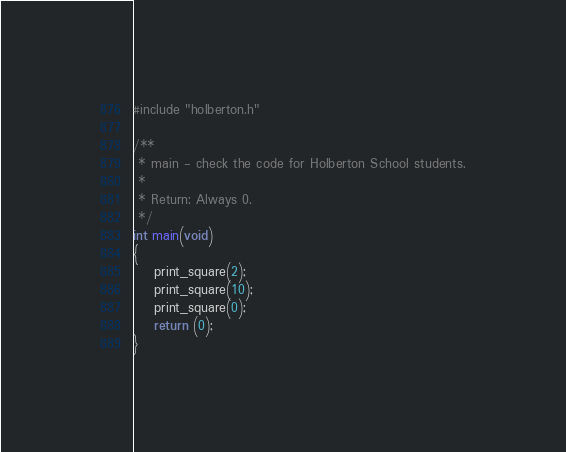<code> <loc_0><loc_0><loc_500><loc_500><_C_>#include "holberton.h"

/**
 * main - check the code for Holberton School students.
 *
 * Return: Always 0.
 */
int main(void)
{
	print_square(2);
	print_square(10);
	print_square(0);
	return (0);
}</code> 